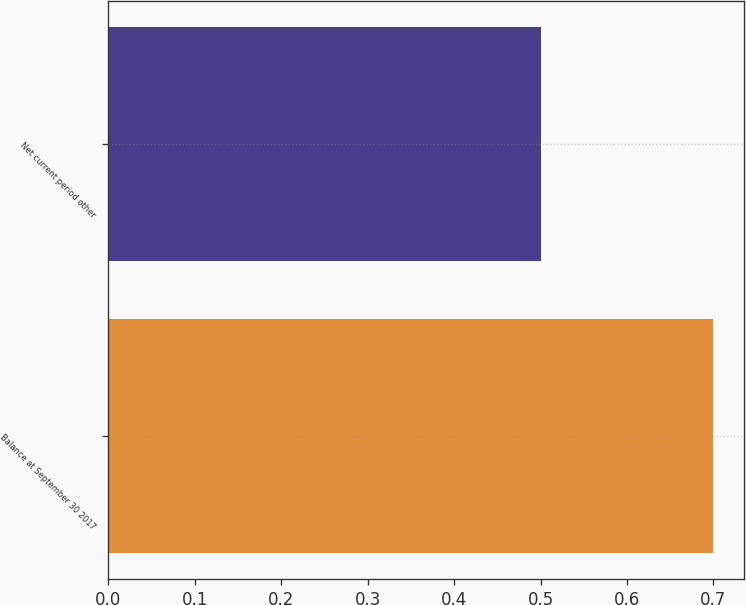Convert chart to OTSL. <chart><loc_0><loc_0><loc_500><loc_500><bar_chart><fcel>Balance at September 30 2017<fcel>Net current period other<nl><fcel>0.7<fcel>0.5<nl></chart> 